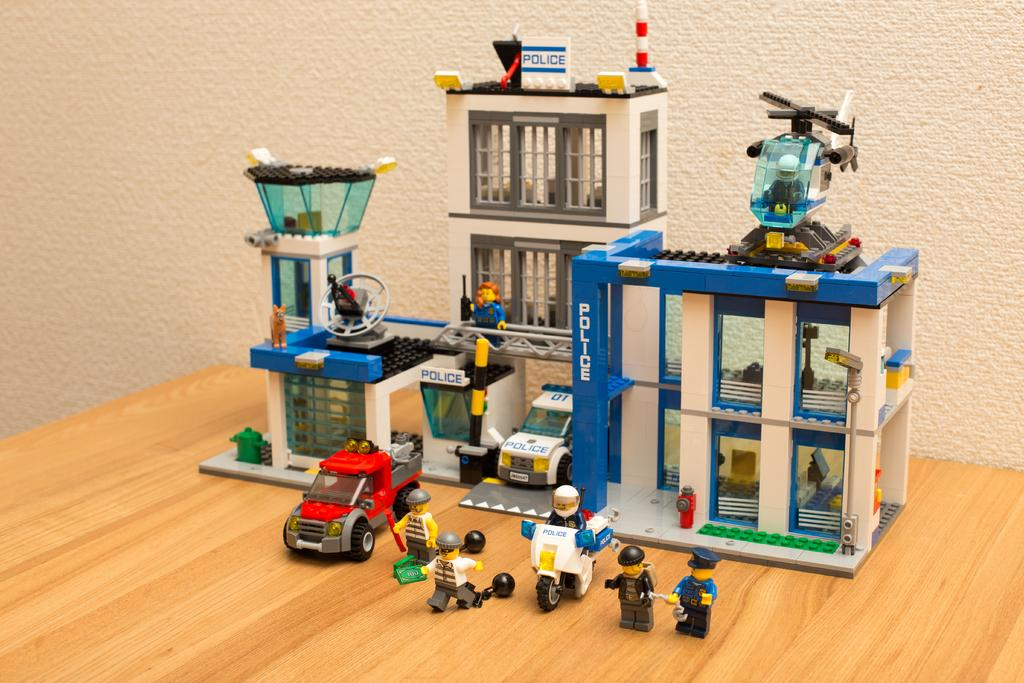What type of toy is present in the image? There is a toy building in the image. What other objects can be seen in the image? There are vehicles and people visible in the image. Can you describe the helicopter in the image? The helicopter is on the roof of the toy building. What type of soda is being consumed by the women in the image? There are no women or soda present in the image. 